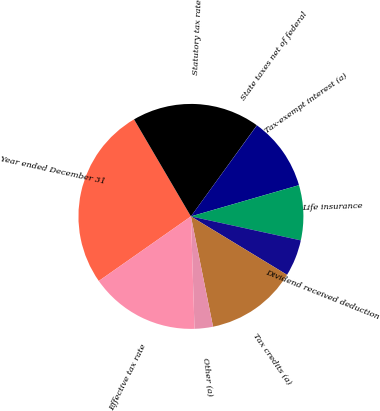<chart> <loc_0><loc_0><loc_500><loc_500><pie_chart><fcel>Year ended December 31<fcel>Statutory tax rate<fcel>State taxes net of federal<fcel>Tax-exempt interest (a)<fcel>Life insurance<fcel>Dividend received deduction<fcel>Tax credits (a)<fcel>Other (a)<fcel>Effective tax rate<nl><fcel>26.29%<fcel>18.41%<fcel>0.02%<fcel>10.53%<fcel>7.9%<fcel>5.27%<fcel>13.16%<fcel>2.64%<fcel>15.78%<nl></chart> 